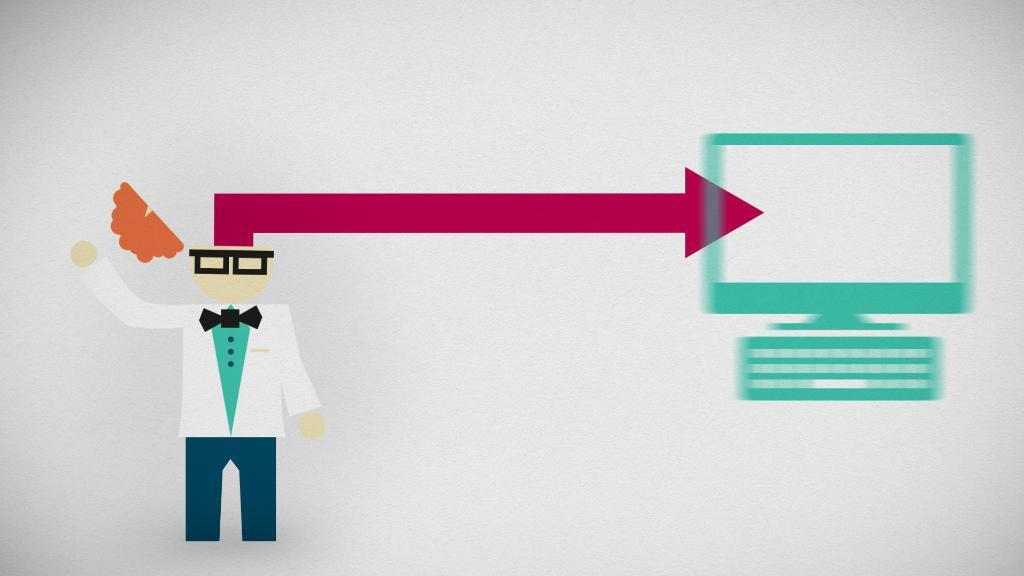In one or two sentences, can you explain what this image depicts? This is animated picture, in this picture we can see a person and we can see monitor and keyboard. 